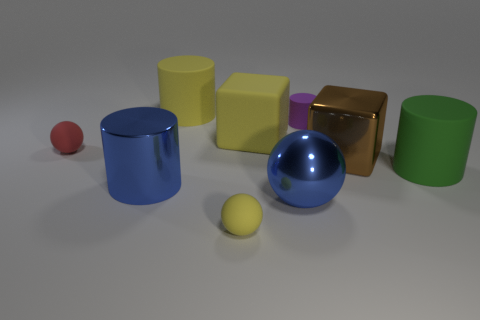What is the material of the big thing that is the same color as the big metallic cylinder?
Ensure brevity in your answer.  Metal. Are there more red matte spheres that are in front of the blue cylinder than yellow rubber cylinders that are on the left side of the yellow cylinder?
Your answer should be compact. No. What number of blue metal objects are the same shape as the red thing?
Your response must be concise. 1. What number of things are either green matte things to the right of the yellow ball or objects on the right side of the red ball?
Provide a succinct answer. 8. What material is the blue thing on the left side of the tiny ball in front of the rubber object on the right side of the brown block?
Give a very brief answer. Metal. There is a matte cylinder in front of the small purple rubber thing; does it have the same color as the big metal cube?
Provide a short and direct response. No. What is the material of the big thing that is in front of the brown shiny cube and to the right of the purple rubber thing?
Offer a very short reply. Rubber. Is there a yellow rubber object that has the same size as the purple thing?
Provide a succinct answer. Yes. What number of matte spheres are there?
Offer a very short reply. 2. What number of yellow matte cubes are right of the tiny cylinder?
Ensure brevity in your answer.  0. 